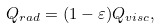<formula> <loc_0><loc_0><loc_500><loc_500>Q _ { r a d } = ( 1 - \varepsilon ) Q _ { v i s c } ,</formula> 